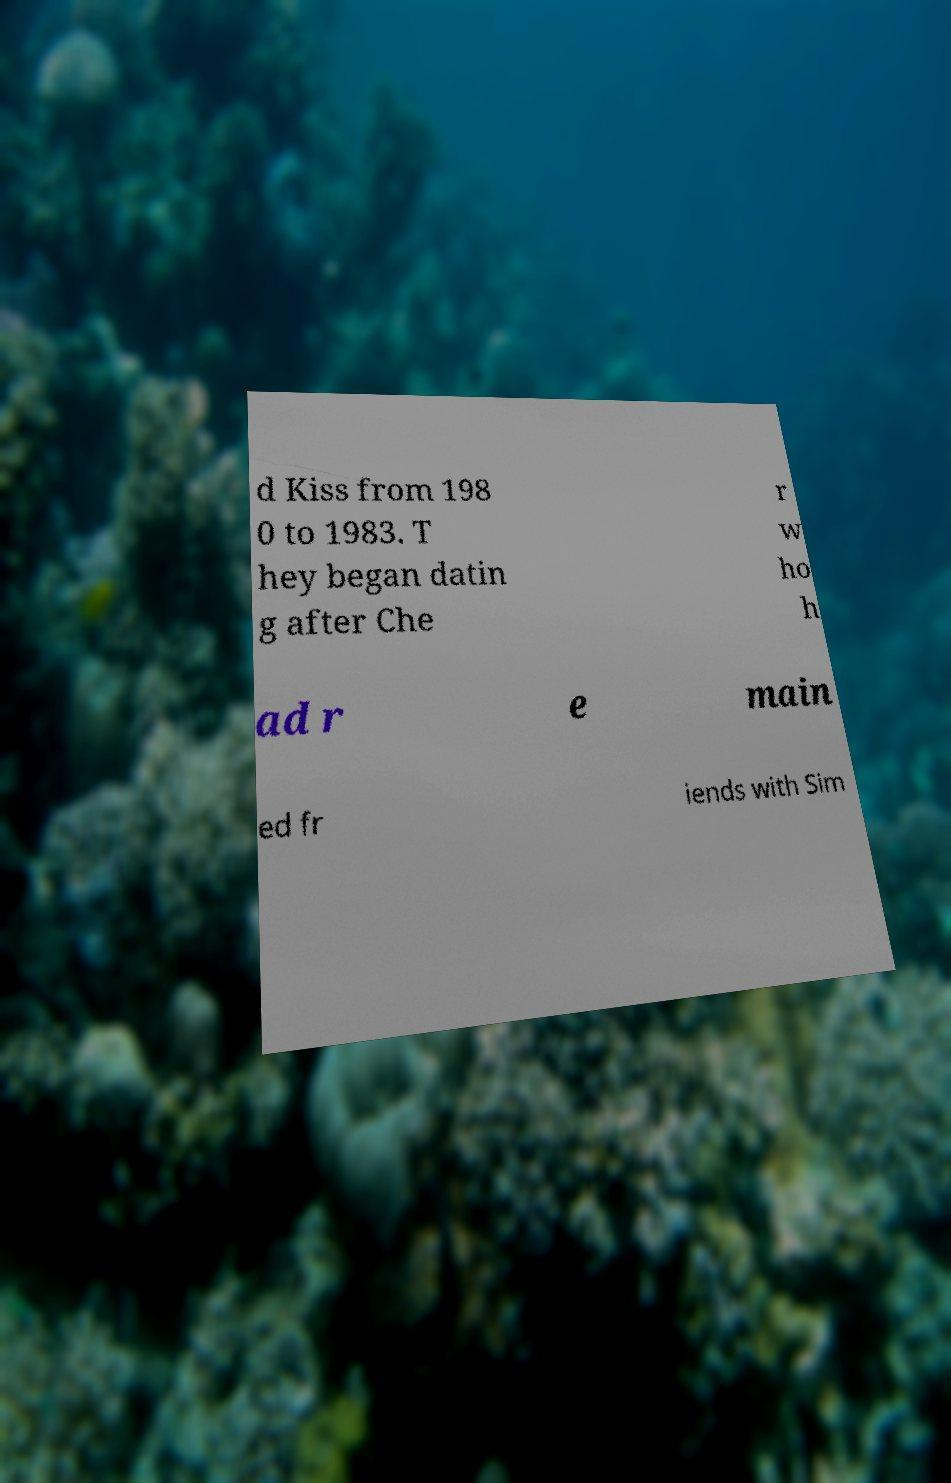Please read and relay the text visible in this image. What does it say? d Kiss from 198 0 to 1983. T hey began datin g after Che r w ho h ad r e main ed fr iends with Sim 